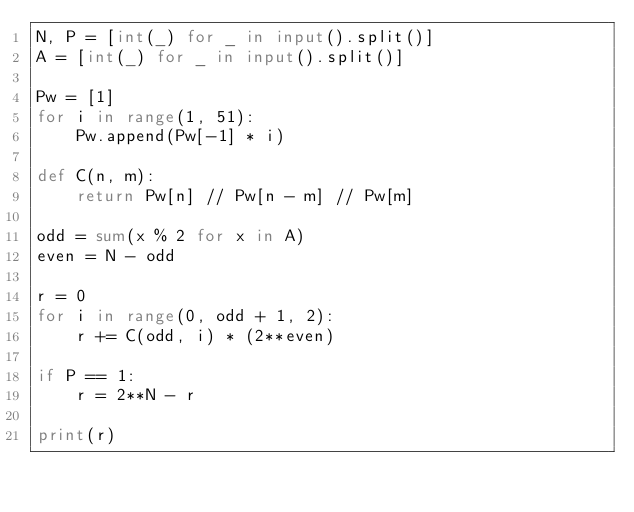Convert code to text. <code><loc_0><loc_0><loc_500><loc_500><_Python_>N, P = [int(_) for _ in input().split()]
A = [int(_) for _ in input().split()]

Pw = [1]
for i in range(1, 51):
    Pw.append(Pw[-1] * i)

def C(n, m):
    return Pw[n] // Pw[n - m] // Pw[m]

odd = sum(x % 2 for x in A)
even = N - odd

r = 0
for i in range(0, odd + 1, 2):
    r += C(odd, i) * (2**even)

if P == 1:
    r = 2**N - r

print(r)
</code> 